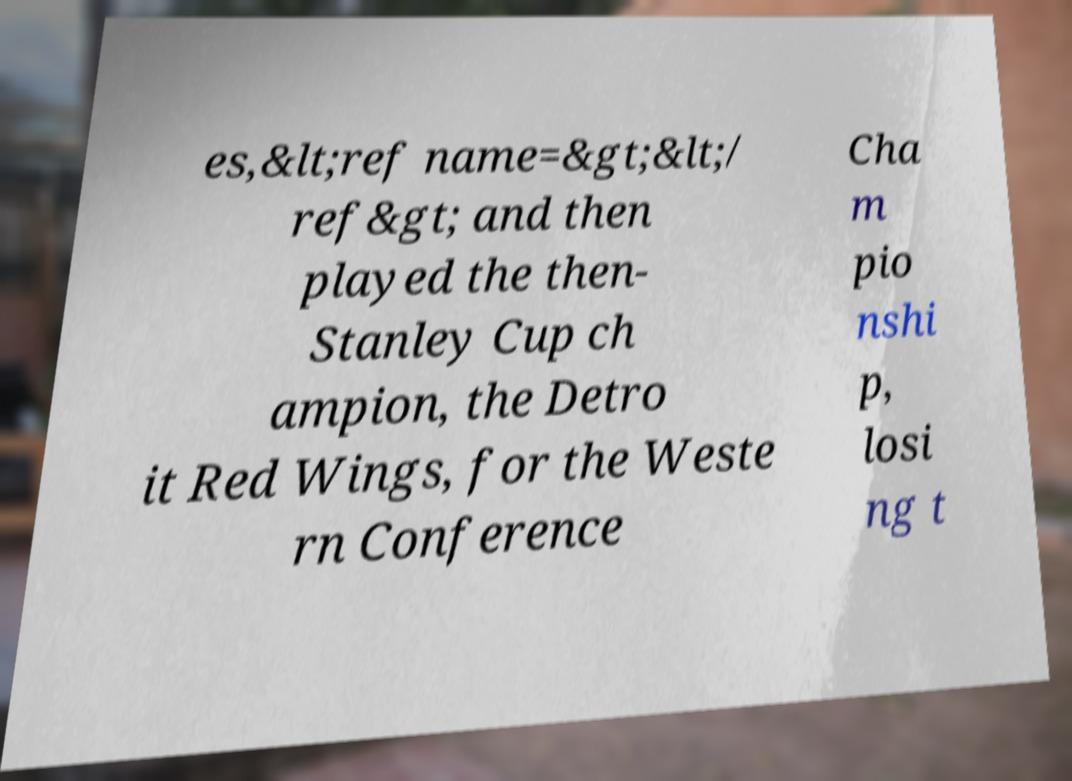Can you accurately transcribe the text from the provided image for me? es,&lt;ref name=&gt;&lt;/ ref&gt; and then played the then- Stanley Cup ch ampion, the Detro it Red Wings, for the Weste rn Conference Cha m pio nshi p, losi ng t 